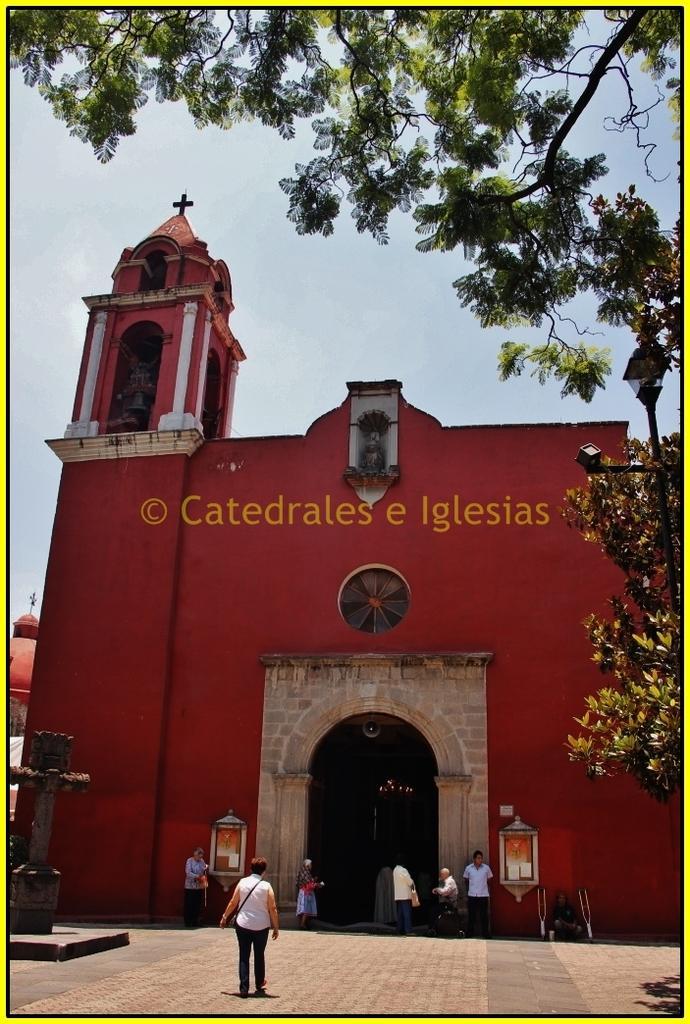What type of structure is visible in the image? There is a building in the image. What architectural feature can be seen on the building? There is an arch in the image. What is written or displayed on the building? There is text on the building. What type of vegetation is present in the image? There are trees in the image. Who or what is present in the image? There are people in the image. What is visible in the background of the image? The sky is visible in the image. How many cacti can be seen in the image? There are no cacti present in the image. What is the temper of the people in the image? The image does not provide information about the temper of the people; it only shows their presence. 